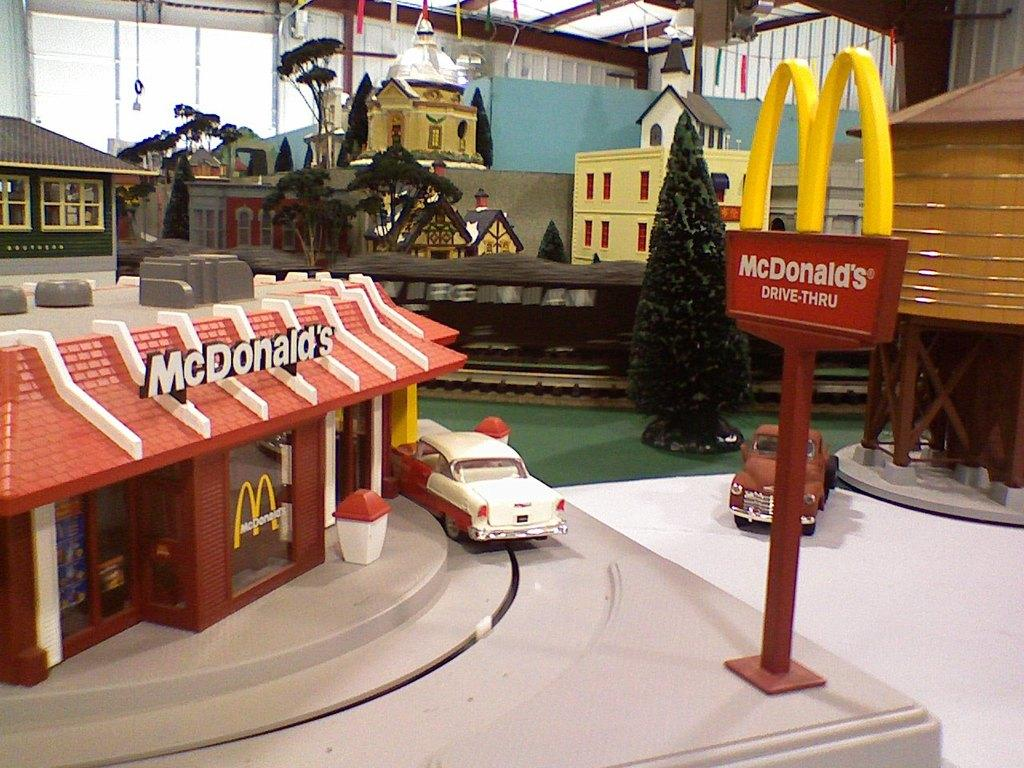What type of structures are present in the image? There are toy houses in the image. What other objects can be seen in the image? There are trees, a pole, a board, and vehicles in the image. What is visible in the background of the image? There is a wall, glass objects, and a pillar in the background of the image. What type of sand can be seen in the image? There is no sand present in the image. Is there an oven visible in the image? There is no oven present in the image. 